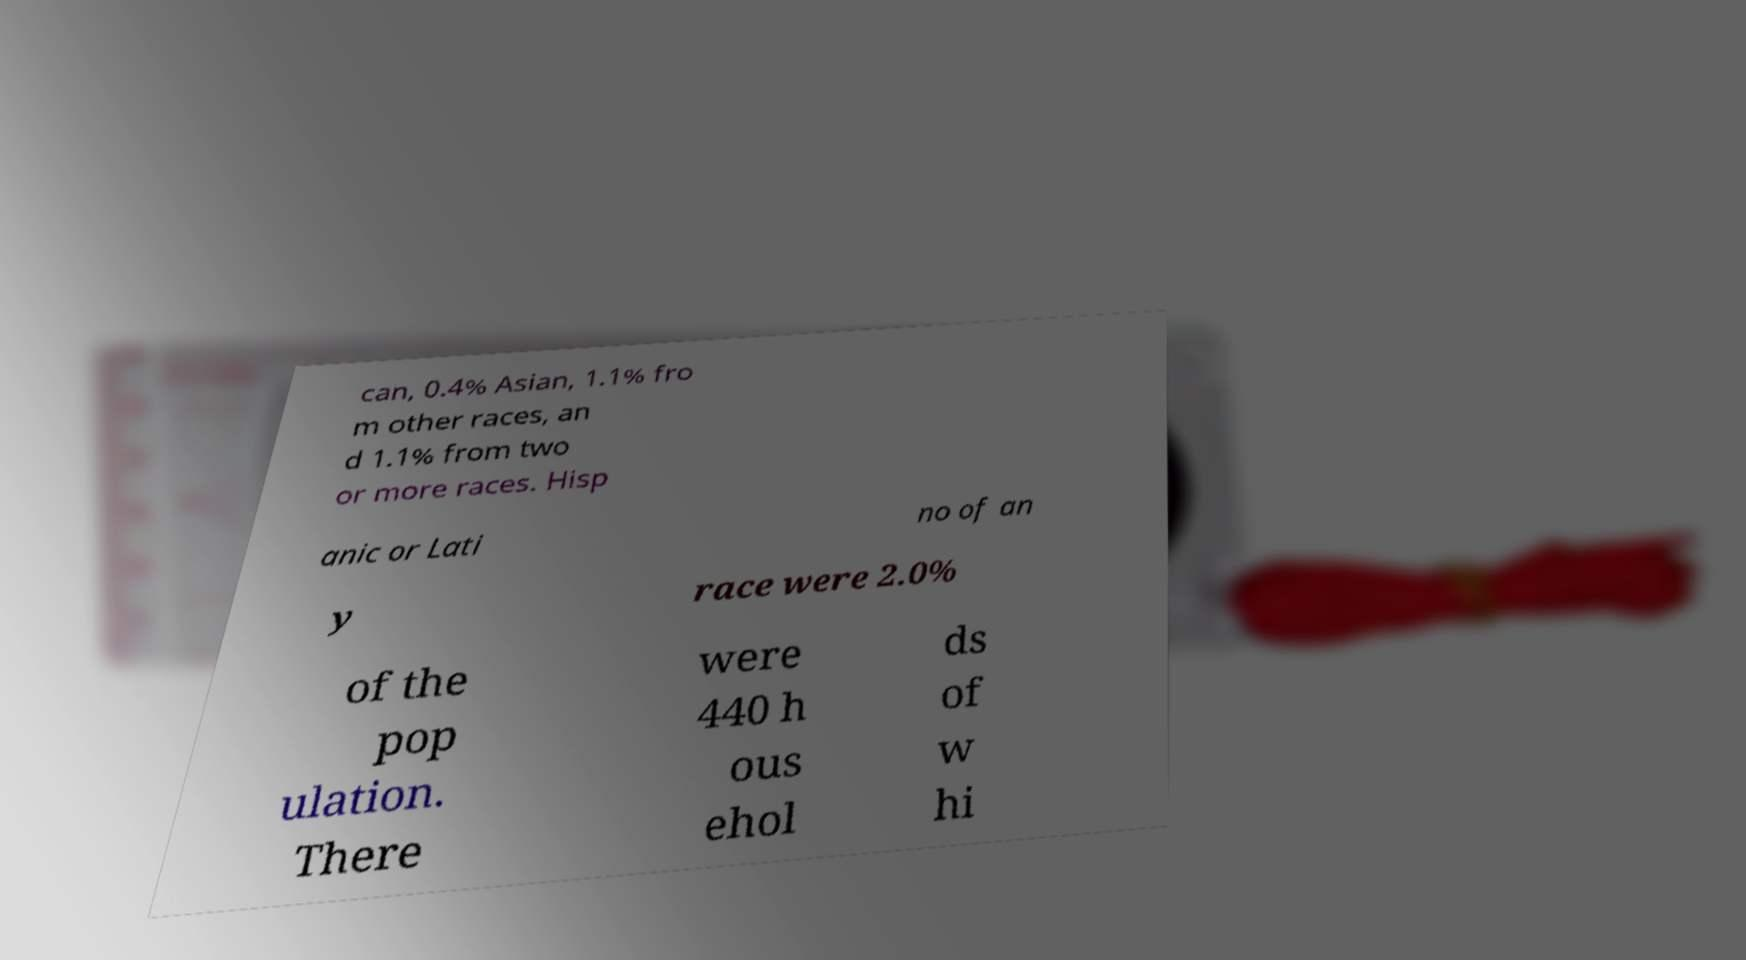I need the written content from this picture converted into text. Can you do that? can, 0.4% Asian, 1.1% fro m other races, an d 1.1% from two or more races. Hisp anic or Lati no of an y race were 2.0% of the pop ulation. There were 440 h ous ehol ds of w hi 